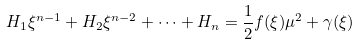<formula> <loc_0><loc_0><loc_500><loc_500>H _ { 1 } \xi ^ { n - 1 } + H _ { 2 } \xi ^ { n - 2 } + \dots + H _ { n } = \frac { 1 } { 2 } f ( \xi ) \mu ^ { 2 } + \gamma ( \xi )</formula> 